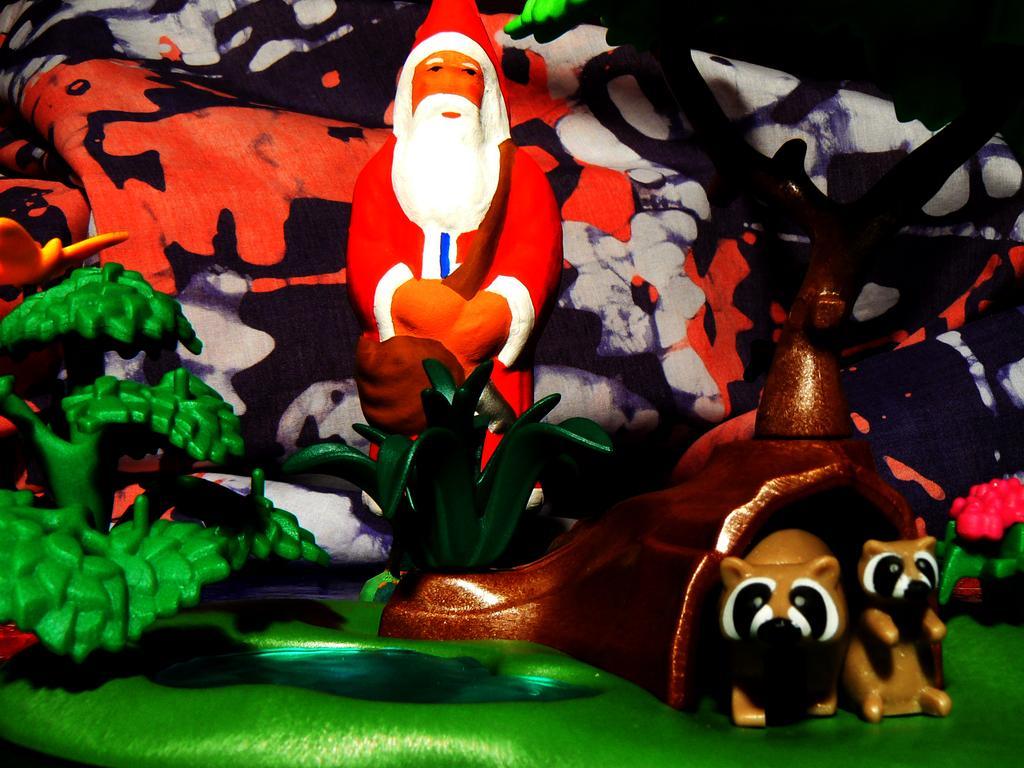Describe this image in one or two sentences. This image contains few dolls. Behind it there is a cloth. There are few animal toys in cave. Beside there is a plant. There is some water near the grassland having a tree. Behind it there is a person doll. 